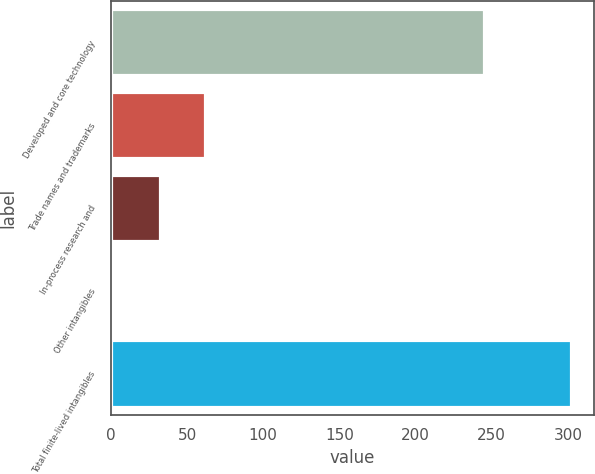<chart> <loc_0><loc_0><loc_500><loc_500><bar_chart><fcel>Developed and core technology<fcel>Trade names and trademarks<fcel>In-process research and<fcel>Other intangibles<fcel>Total finite-lived intangibles<nl><fcel>245<fcel>62<fcel>32<fcel>2<fcel>302<nl></chart> 